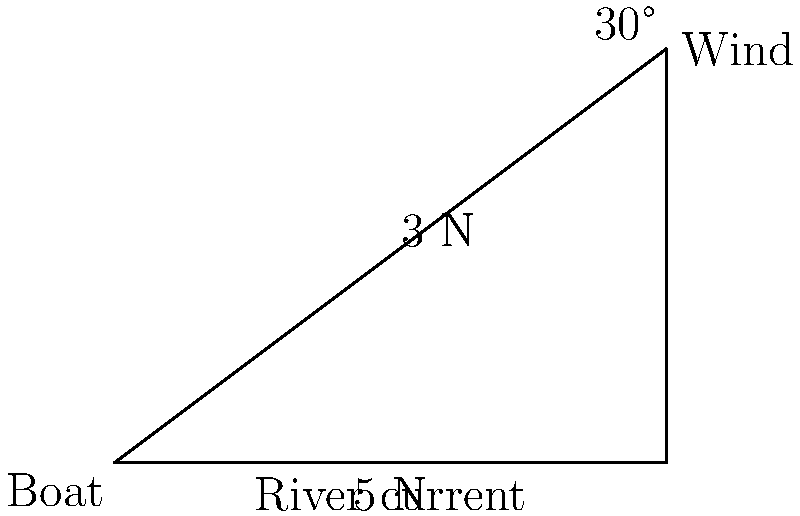During an ecotour on the Mahanadi River in Odisha, a boat is subjected to a 5 N river current force eastward and a 3 N wind force at a 30° angle north of east. Calculate the magnitude of the resultant force acting on the boat. To find the resultant force, we need to use vector addition. Let's break this down step-by-step:

1) First, let's define our coordinate system:
   - East is the positive x-direction
   - North is the positive y-direction

2) Now, let's break down the forces into their x and y components:
   - River current: $F_r = 5$ N, all in x-direction
   - Wind: $F_w = 3$ N at 30° above x-axis
     $F_{wx} = 3 \cos(30°) = 3 \cdot \frac{\sqrt{3}}{2} = 3\sqrt{3}/2$ N
     $F_{wy} = 3 \sin(30°) = 3 \cdot \frac{1}{2} = 3/2$ N

3) Now we can sum the forces in each direction:
   $F_x = 5 + 3\sqrt{3}/2$ N
   $F_y = 3/2$ N

4) The resultant force is the vector sum of these components. We can find its magnitude using the Pythagorean theorem:

   $F_{resultant} = \sqrt{F_x^2 + F_y^2}$

   $= \sqrt{(5 + 3\sqrt{3}/2)^2 + (3/2)^2}$

   $= \sqrt{25 + 15\sqrt{3} + 27/4 + 9/4}$

   $= \sqrt{25 + 15\sqrt{3} + 9}$

   $= \sqrt{34 + 15\sqrt{3}}$ N

5) This can be simplified to:

   $F_{resultant} = \sqrt{34 + 15\sqrt{3}}$ N ≈ 7.79 N
Answer: $\sqrt{34 + 15\sqrt{3}}$ N 